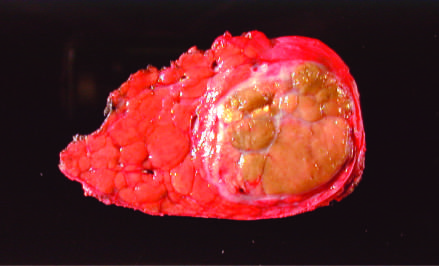does the liver removed at autopsy show a unifocal, massive neoplasm replacing most of the right hepatic lobe in a noncirrhotic liver?
Answer the question using a single word or phrase. Yes 